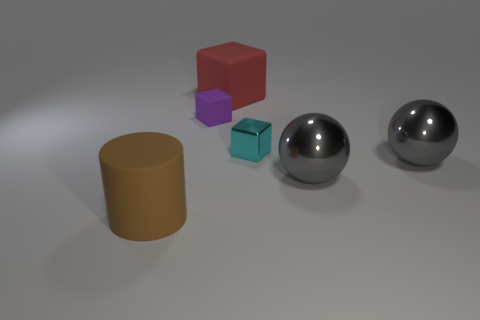Add 3 big gray objects. How many objects exist? 9 Subtract all balls. How many objects are left? 4 Add 5 red rubber things. How many red rubber things exist? 6 Subtract 0 purple cylinders. How many objects are left? 6 Subtract all big gray balls. Subtract all big gray metallic spheres. How many objects are left? 2 Add 2 large gray shiny objects. How many large gray shiny objects are left? 4 